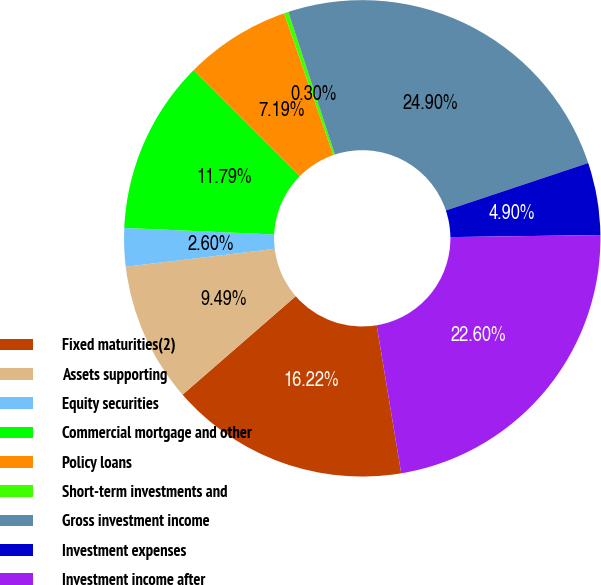<chart> <loc_0><loc_0><loc_500><loc_500><pie_chart><fcel>Fixed maturities(2)<fcel>Assets supporting<fcel>Equity securities<fcel>Commercial mortgage and other<fcel>Policy loans<fcel>Short-term investments and<fcel>Gross investment income<fcel>Investment expenses<fcel>Investment income after<nl><fcel>16.22%<fcel>9.49%<fcel>2.6%<fcel>11.79%<fcel>7.19%<fcel>0.3%<fcel>24.9%<fcel>4.9%<fcel>22.6%<nl></chart> 